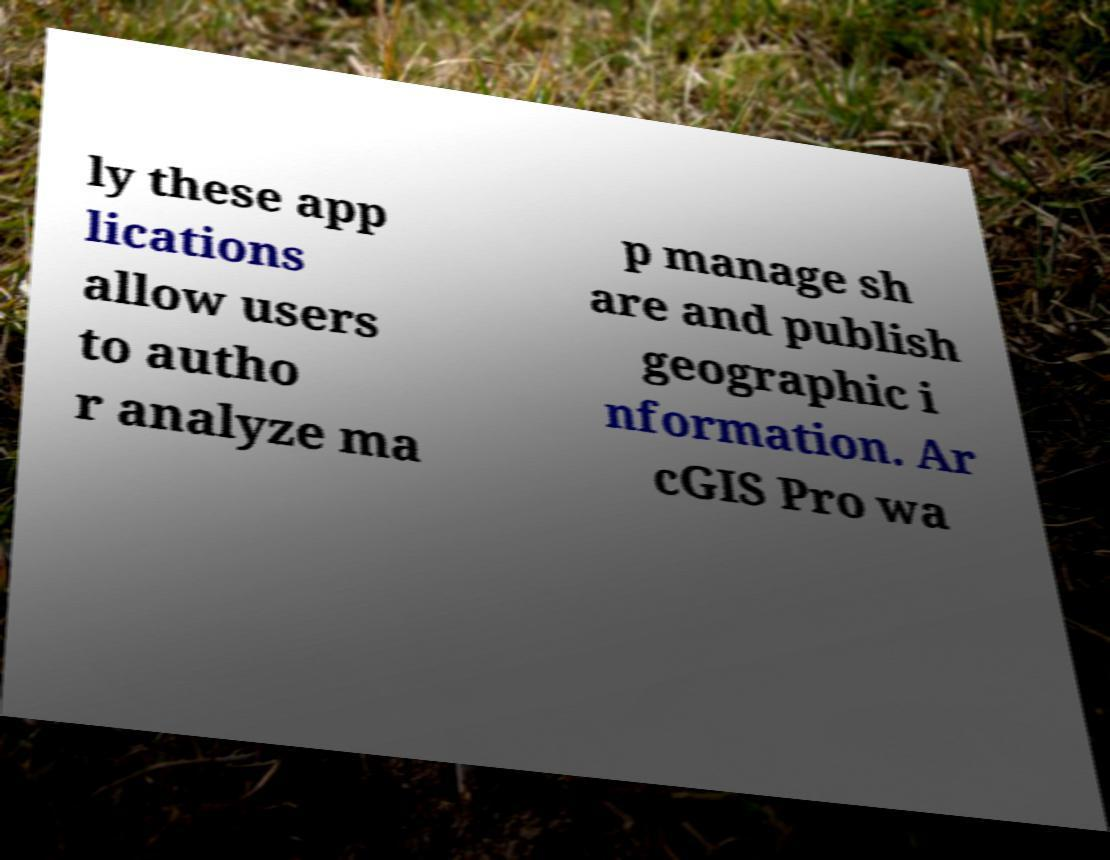Please read and relay the text visible in this image. What does it say? ly these app lications allow users to autho r analyze ma p manage sh are and publish geographic i nformation. Ar cGIS Pro wa 